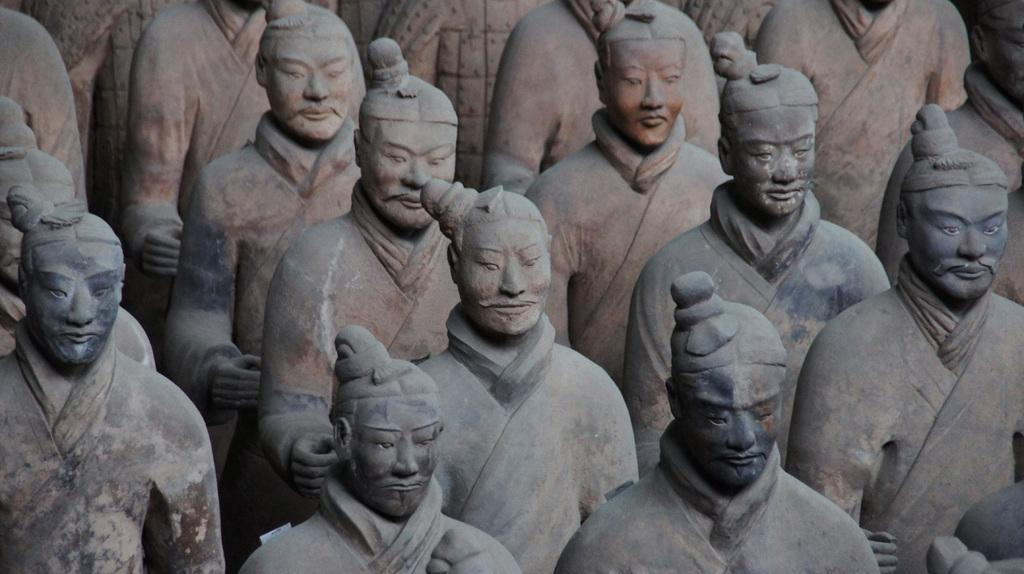What type of sculptures can be seen in the image? There are sculptures of china warriors in the image. What is the color of the sculptures? The sculptures are grey in color. How many wheels are on the sculptures in the image? The sculptures in the image are stationary and do not have wheels. 